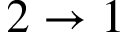Convert formula to latex. <formula><loc_0><loc_0><loc_500><loc_500>2 \to 1</formula> 